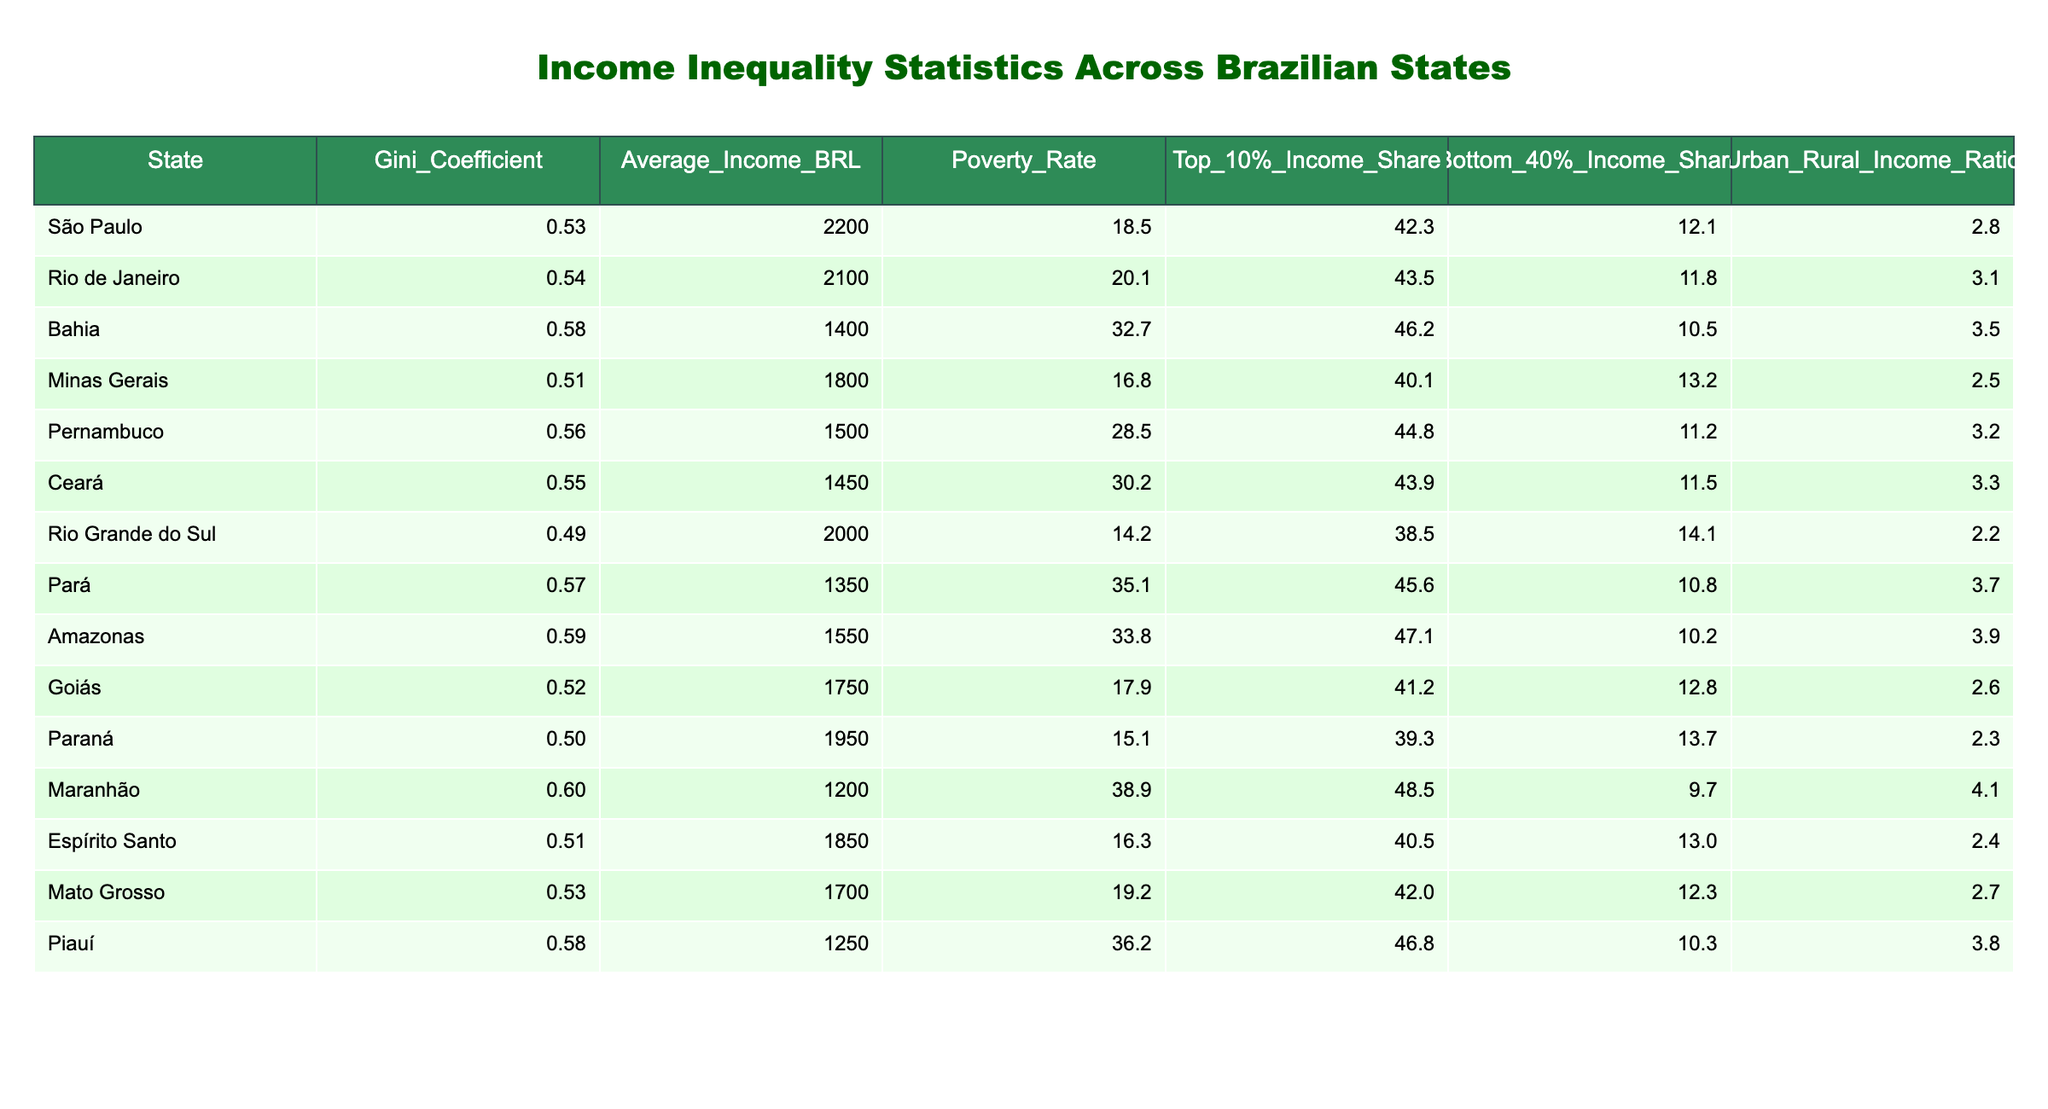What is the Gini Coefficient for Minas Gerais? According to the table, the Gini Coefficient is a measure of income inequality. For Minas Gerais, the Gini Coefficient value is listed as 0.51.
Answer: 0.51 Which state has the highest average income? By examining the Average Income column in the table, São Paulo has the highest value listed at 2200 BRL.
Answer: 2200 BRL What is the poverty rate in Maranhão? Looking at the table, the Poverty Rate for Maranhão is provided as 38.9%.
Answer: 38.9% Which state has the lowest Bottom 40% Income Share? The table shows that Maranhão has the lowest Bottom 40% Income Share at 9.7%.
Answer: 9.7% Is the Urban-Rural Income Ratio higher in Bahia than in Espírito Santo? The Urban-Rural Income Ratios for Bahia and Espírito Santo are 3.5 and 2.4, respectively. Comparing these values, Bahia has a higher ratio than Espírito Santo.
Answer: Yes What is the average Gini Coefficient of all the states listed? To find the average Gini Coefficient, add up all the Gini values (0.53 + 0.54 + 0.58 + 0.51 + 0.56 + 0.55 + 0.49 + 0.57 + 0.59 + 0.52 + 0.50 + 0.60 + 0.51 + 0.53 + 0.58) which equals 8.21, and divide by 15 (the number of states) to get approximately 0.548.
Answer: 0.55 Which state has the highest Top 10% Income Share? The table indicates that Maranhão has the highest Top 10% Income Share at 48.5%.
Answer: 48.5% How many states have a Gini Coefficient greater than 0.55? Inspecting the Gini Coefficient values, Bahia, Rio de Janeiro, Amazonas, and Maranhão have values greater than 0.55. That totals to four states.
Answer: 4 What is the difference in Average Income between São Paulo and Pará? São Paulo has an Average Income of 2200 BRL and Pará has 1350 BRL. The difference is calculated as 2200 - 1350 = 850 BRL.
Answer: 850 BRL Which state has a higher poverty rate: Pará or Bahia? The Poverty Rate for Pará is given as 35.1% while Bahia's rate is 32.7%. Thus, Pará has a higher poverty rate than Bahia.
Answer: Pará What is the Urban-Rural Income Ratio for the state with the lowest Average Income? The lowest Average Income is in Maranhão at 1200 BRL, and its Urban-Rural Income Ratio is 4.1, as presented in the table.
Answer: 4.1 